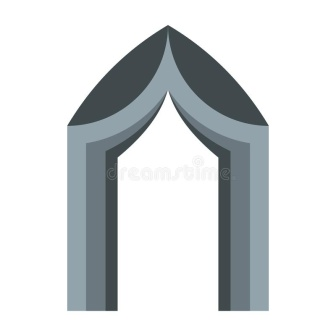What stories could this solitary archway tell if it could speak? If this solitary archway could speak, it might tell tales of countless generations that have passed beneath its stone embrace. It might speak of grand celebrations and solemn processions, of joyful reunions and tearful farewells. The archway could recount the clang of armor as knights rode off to battle and the echo of prayers offered by those seeking solace. It might whisper about secret midnight rendezvous shared by star-crossed lovers and clandestine meetings of political intrigue. The archway, a silent witness to history, would have tales of prosperity and hardship, of the cyclical nature of human experience unfolding around it through the ages. 